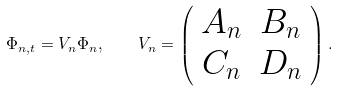Convert formula to latex. <formula><loc_0><loc_0><loc_500><loc_500>\Phi _ { n , t } = V _ { n } \Phi _ { n } , \quad V _ { n } = \left ( \begin{array} { c c } A _ { n } & B _ { n } \\ C _ { n } & D _ { n } \end{array} \right ) .</formula> 